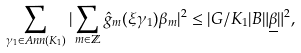Convert formula to latex. <formula><loc_0><loc_0><loc_500><loc_500>\sum _ { \gamma _ { 1 } \in A n n ( K _ { 1 } ) } | \sum _ { m \in \mathbb { Z } } \hat { g } _ { m } ( \xi \gamma _ { 1 } ) \beta _ { m } | ^ { 2 } \leq | G / { K _ { 1 } } | B \| \underline { \beta } \| ^ { 2 } ,</formula> 